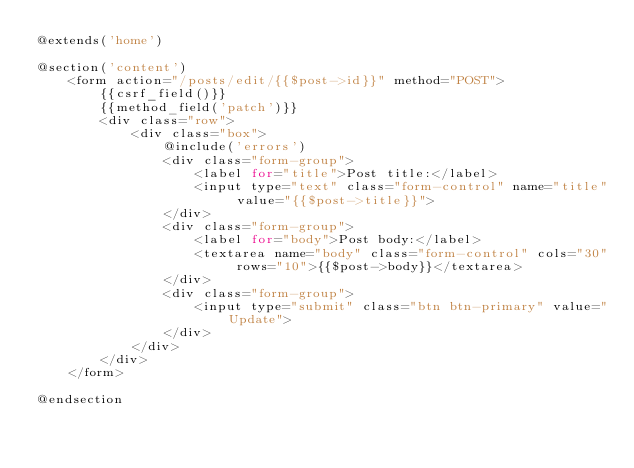<code> <loc_0><loc_0><loc_500><loc_500><_PHP_>@extends('home')

@section('content')
    <form action="/posts/edit/{{$post->id}}" method="POST">
        {{csrf_field()}}
        {{method_field('patch')}}
        <div class="row">
            <div class="box">
                @include('errors')
                <div class="form-group">
                    <label for="title">Post title:</label>
                    <input type="text" class="form-control" name="title" value="{{$post->title}}">
                </div>
                <div class="form-group">
                    <label for="body">Post body:</label>
                    <textarea name="body" class="form-control" cols="30" rows="10">{{$post->body}}</textarea>
                </div>
                <div class="form-group">
                    <input type="submit" class="btn btn-primary" value="Update">
                </div>
            </div>
        </div>
    </form>

@endsection</code> 